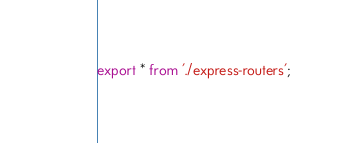Convert code to text. <code><loc_0><loc_0><loc_500><loc_500><_TypeScript_>export * from './express-routers';
</code> 